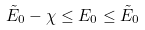<formula> <loc_0><loc_0><loc_500><loc_500>\tilde { E } _ { 0 } - \chi \leq E _ { 0 } \leq \tilde { E } _ { 0 }</formula> 